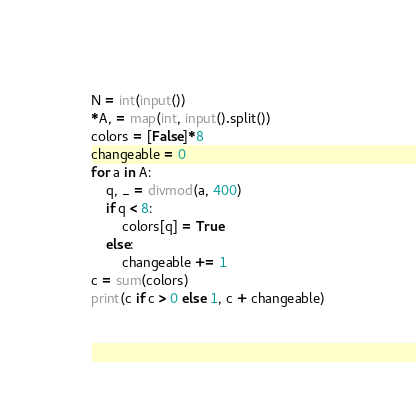Convert code to text. <code><loc_0><loc_0><loc_500><loc_500><_Python_>N = int(input())
*A, = map(int, input().split())
colors = [False]*8
changeable = 0
for a in A:
    q, _ = divmod(a, 400)
    if q < 8:
        colors[q] = True
    else:
        changeable += 1
c = sum(colors)
print(c if c > 0 else 1, c + changeable)</code> 